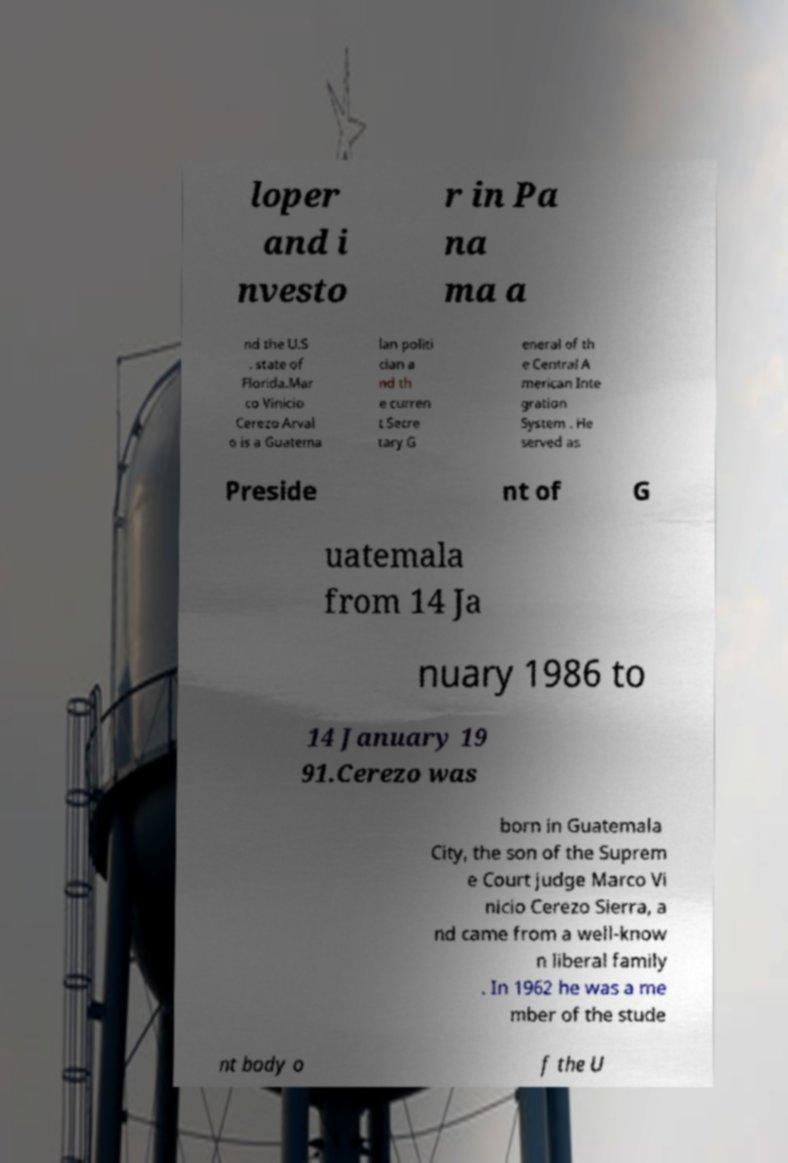What messages or text are displayed in this image? I need them in a readable, typed format. loper and i nvesto r in Pa na ma a nd the U.S . state of Florida.Mar co Vinicio Cerezo Arval o is a Guatema lan politi cian a nd th e curren t Secre tary G eneral of th e Central A merican Inte gration System . He served as Preside nt of G uatemala from 14 Ja nuary 1986 to 14 January 19 91.Cerezo was born in Guatemala City, the son of the Suprem e Court judge Marco Vi nicio Cerezo Sierra, a nd came from a well-know n liberal family . In 1962 he was a me mber of the stude nt body o f the U 